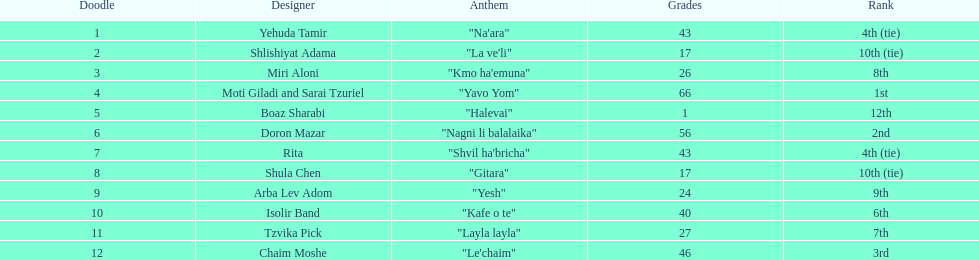What are the number of times an artist earned first place? 1. 